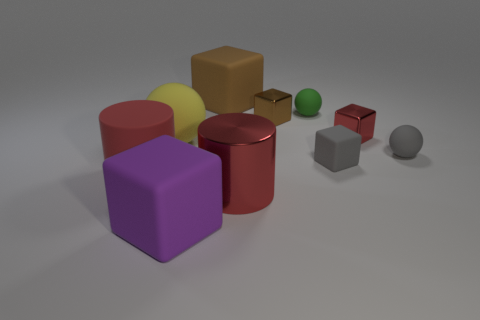What number of other things are the same shape as the green thing?
Offer a very short reply. 2. Does the brown object that is behind the tiny green sphere have the same shape as the red thing that is in front of the large red matte cylinder?
Offer a terse response. No. Are there an equal number of large red objects that are on the right side of the red block and big matte things in front of the gray cube?
Provide a succinct answer. No. There is a large red thing on the right side of the cylinder on the left side of the large red cylinder that is in front of the red rubber cylinder; what is its shape?
Offer a terse response. Cylinder. Are the small ball that is behind the tiny brown block and the small object in front of the gray sphere made of the same material?
Your answer should be very brief. Yes. What shape is the rubber object in front of the big matte cylinder?
Your answer should be compact. Cube. Are there fewer brown cubes than matte cubes?
Make the answer very short. Yes. There is a tiny matte sphere right of the tiny gray object that is on the left side of the tiny gray sphere; is there a red rubber cylinder that is on the right side of it?
Provide a short and direct response. No. How many matte things are either small gray balls or large yellow balls?
Your answer should be compact. 2. Do the rubber cylinder and the large matte ball have the same color?
Provide a succinct answer. No. 